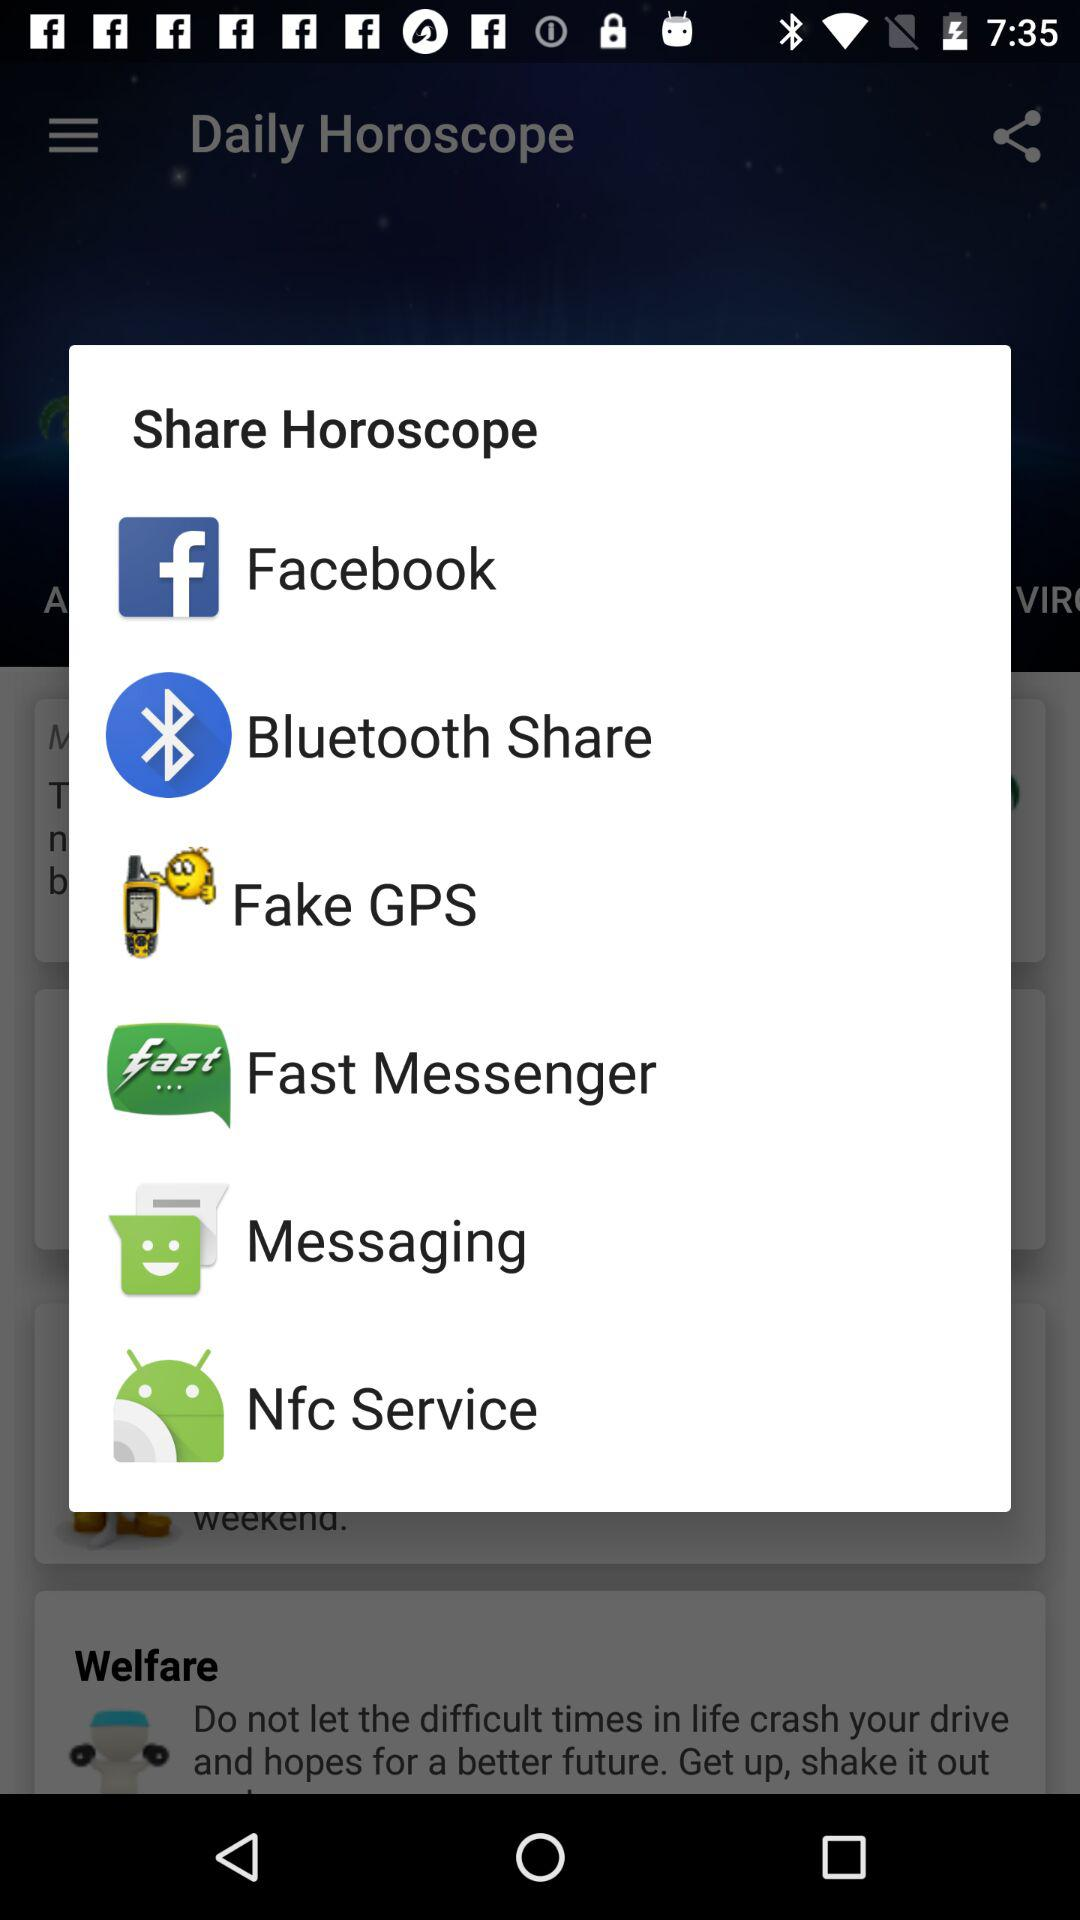Through which applications can we share horoscope? You can share horoscope through "Facebook", "Bluetooth Share", "Fake GPS", "Fast Messenger", "Messaging" and "Nfc Service". 